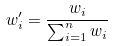Convert formula to latex. <formula><loc_0><loc_0><loc_500><loc_500>w _ { i } ^ { \prime } = \frac { w _ { i } } { \sum _ { i = 1 } ^ { n } w _ { i } }</formula> 